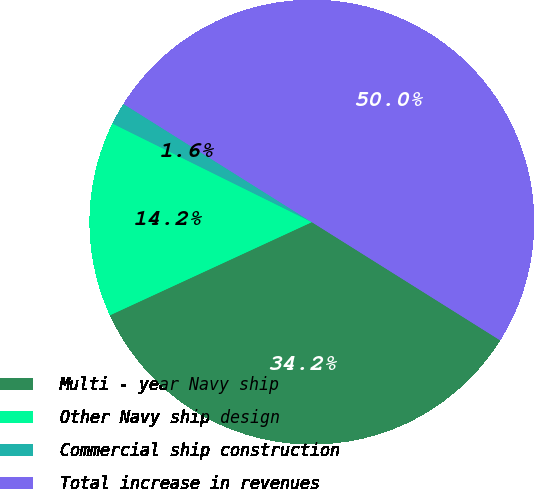Convert chart to OTSL. <chart><loc_0><loc_0><loc_500><loc_500><pie_chart><fcel>Multi - year Navy ship<fcel>Other Navy ship design<fcel>Commercial ship construction<fcel>Total increase in revenues<nl><fcel>34.2%<fcel>14.19%<fcel>1.61%<fcel>50.0%<nl></chart> 